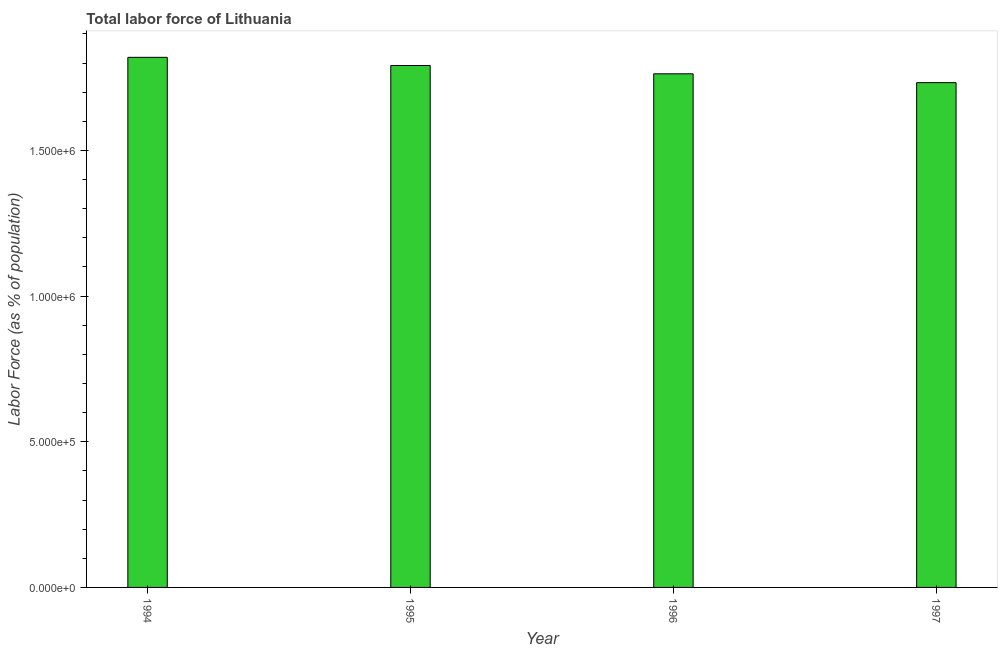What is the title of the graph?
Give a very brief answer. Total labor force of Lithuania. What is the label or title of the Y-axis?
Ensure brevity in your answer.  Labor Force (as % of population). What is the total labor force in 1997?
Provide a short and direct response. 1.73e+06. Across all years, what is the maximum total labor force?
Your response must be concise. 1.82e+06. Across all years, what is the minimum total labor force?
Offer a very short reply. 1.73e+06. In which year was the total labor force maximum?
Offer a very short reply. 1994. What is the sum of the total labor force?
Offer a very short reply. 7.11e+06. What is the difference between the total labor force in 1994 and 1996?
Make the answer very short. 5.65e+04. What is the average total labor force per year?
Make the answer very short. 1.78e+06. What is the median total labor force?
Give a very brief answer. 1.78e+06. In how many years, is the total labor force greater than 600000 %?
Give a very brief answer. 4. What is the difference between the highest and the second highest total labor force?
Your response must be concise. 2.81e+04. What is the difference between the highest and the lowest total labor force?
Offer a very short reply. 8.69e+04. In how many years, is the total labor force greater than the average total labor force taken over all years?
Offer a terse response. 2. Are all the bars in the graph horizontal?
Give a very brief answer. No. How many years are there in the graph?
Your response must be concise. 4. What is the difference between two consecutive major ticks on the Y-axis?
Offer a terse response. 5.00e+05. What is the Labor Force (as % of population) of 1994?
Offer a very short reply. 1.82e+06. What is the Labor Force (as % of population) of 1995?
Make the answer very short. 1.79e+06. What is the Labor Force (as % of population) in 1996?
Your answer should be very brief. 1.76e+06. What is the Labor Force (as % of population) of 1997?
Ensure brevity in your answer.  1.73e+06. What is the difference between the Labor Force (as % of population) in 1994 and 1995?
Ensure brevity in your answer.  2.81e+04. What is the difference between the Labor Force (as % of population) in 1994 and 1996?
Give a very brief answer. 5.65e+04. What is the difference between the Labor Force (as % of population) in 1994 and 1997?
Keep it short and to the point. 8.69e+04. What is the difference between the Labor Force (as % of population) in 1995 and 1996?
Offer a terse response. 2.85e+04. What is the difference between the Labor Force (as % of population) in 1995 and 1997?
Ensure brevity in your answer.  5.88e+04. What is the difference between the Labor Force (as % of population) in 1996 and 1997?
Keep it short and to the point. 3.03e+04. What is the ratio of the Labor Force (as % of population) in 1994 to that in 1995?
Your response must be concise. 1.02. What is the ratio of the Labor Force (as % of population) in 1994 to that in 1996?
Your response must be concise. 1.03. What is the ratio of the Labor Force (as % of population) in 1994 to that in 1997?
Offer a very short reply. 1.05. What is the ratio of the Labor Force (as % of population) in 1995 to that in 1997?
Your answer should be very brief. 1.03. 